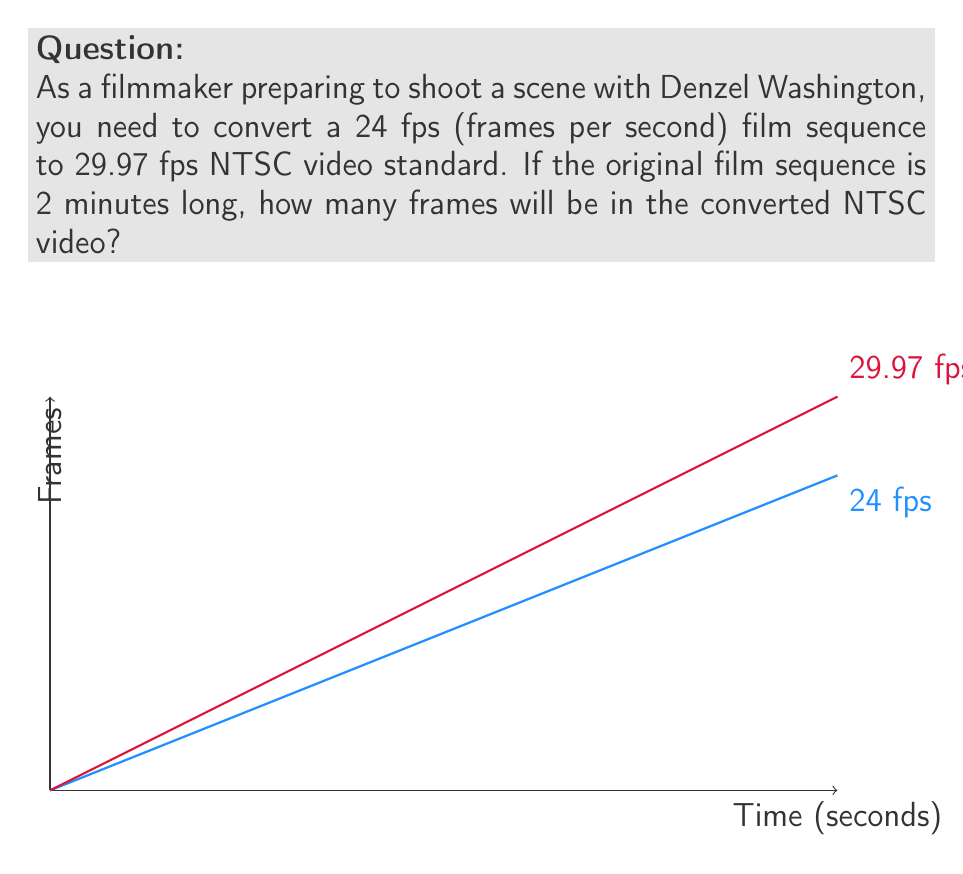What is the answer to this math problem? Let's approach this step-by-step:

1) First, let's calculate the number of frames in the original 24 fps sequence:
   - 2 minutes = 120 seconds
   - Number of frames = $120 \text{ seconds} \times 24 \text{ fps} = 2880 \text{ frames}$

2) Now, we need to convert this to 29.97 fps. We can set up a proportion:
   
   $$\frac{24 \text{ frames}}{1 \text{ second}} = \frac{2880 \text{ frames}}{x \text{ seconds}}$$

3) Solving for x:
   
   $$x = \frac{2880}{24} = 120 \text{ seconds}$$

   This confirms our original duration of 120 seconds.

4) Now, we can calculate the number of frames in 120 seconds at 29.97 fps:
   
   $$120 \text{ seconds} \times 29.97 \text{ fps} = 3596.4 \text{ frames}$$

5) Since we can't have a fractional frame, we round this to the nearest whole number:
   
   $$3596.4 \approx 3596 \text{ frames}$$

Therefore, the 2-minute sequence converted from 24 fps to 29.97 fps will contain 3596 frames.
Answer: 3596 frames 